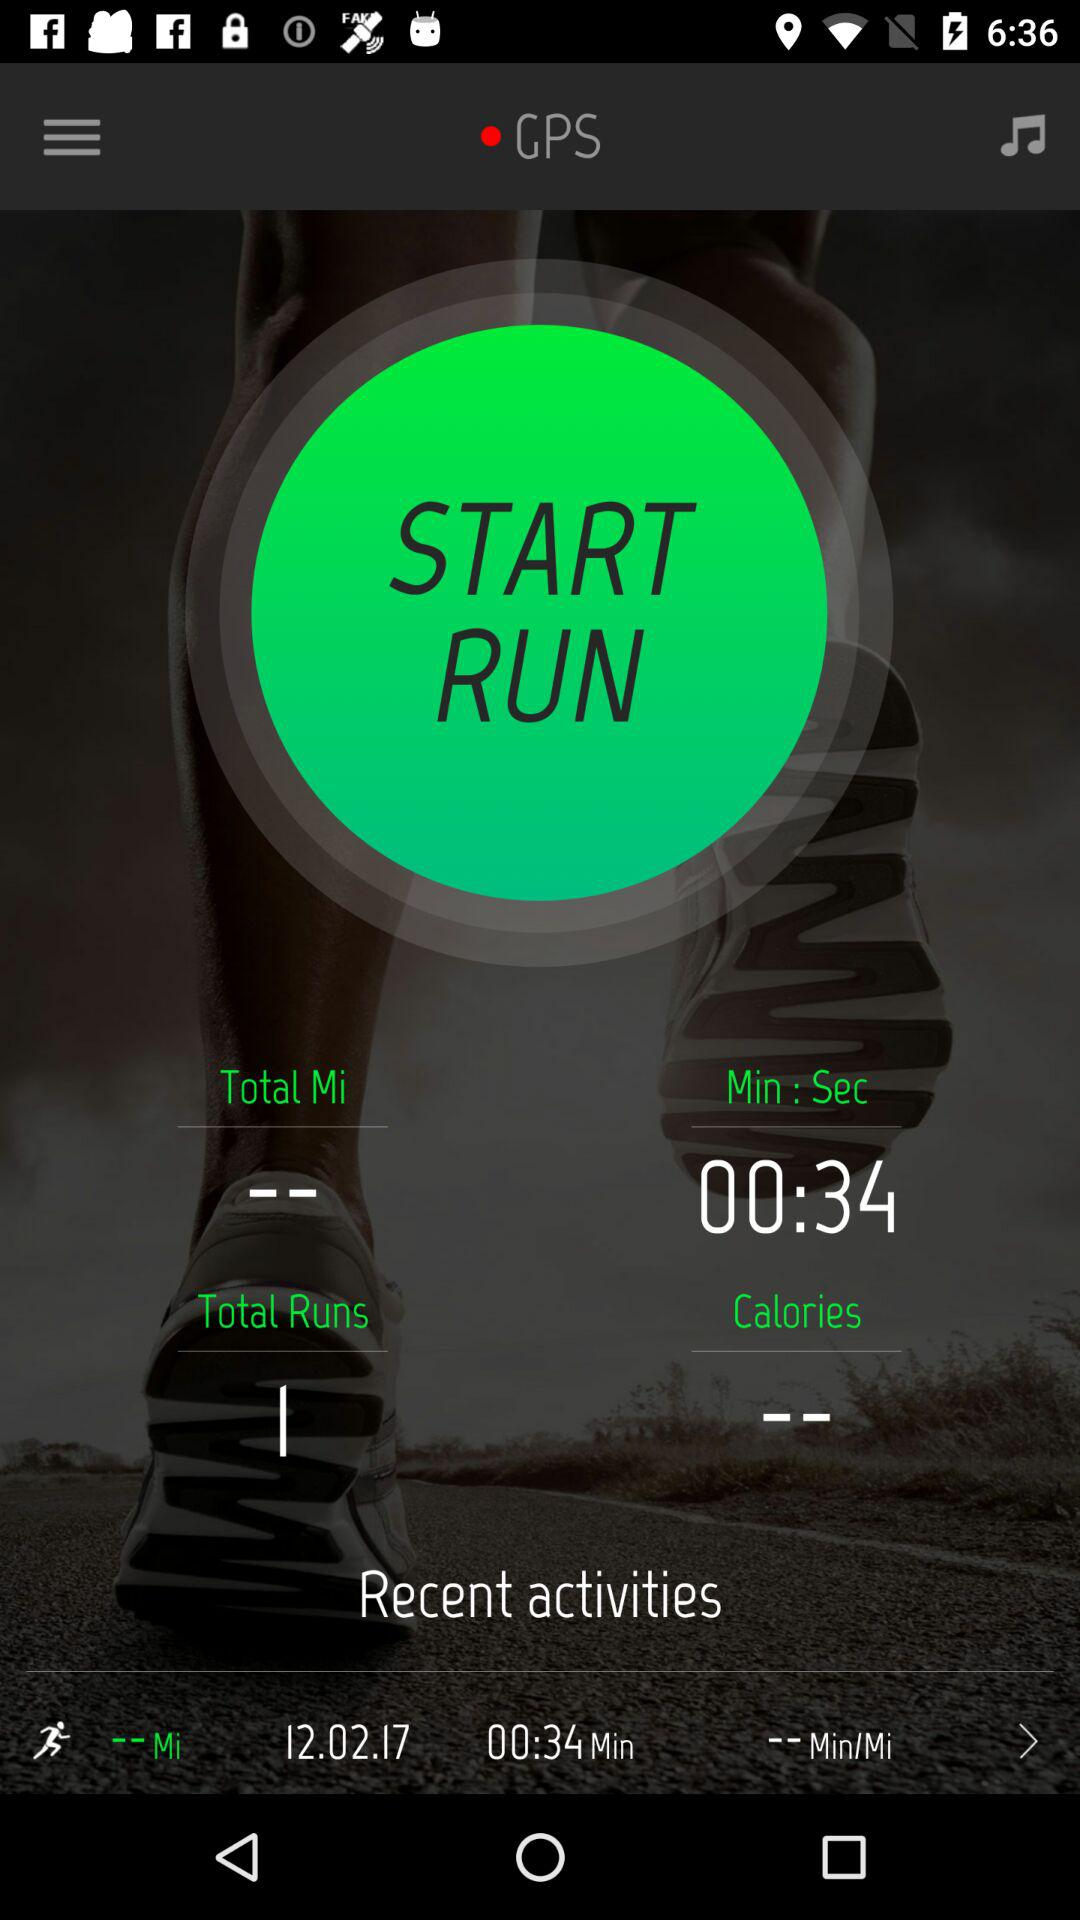What are the mentioned total runs? The number of total runs is 1. 